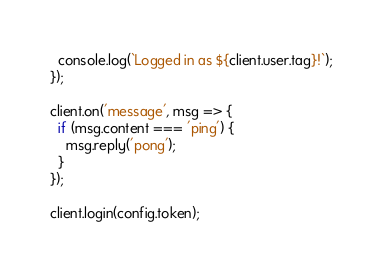Convert code to text. <code><loc_0><loc_0><loc_500><loc_500><_JavaScript_>  console.log(`Logged in as ${client.user.tag}!`);
});

client.on('message', msg => {
  if (msg.content === 'ping') {
    msg.reply('pong');
  }
});

client.login(config.token);</code> 